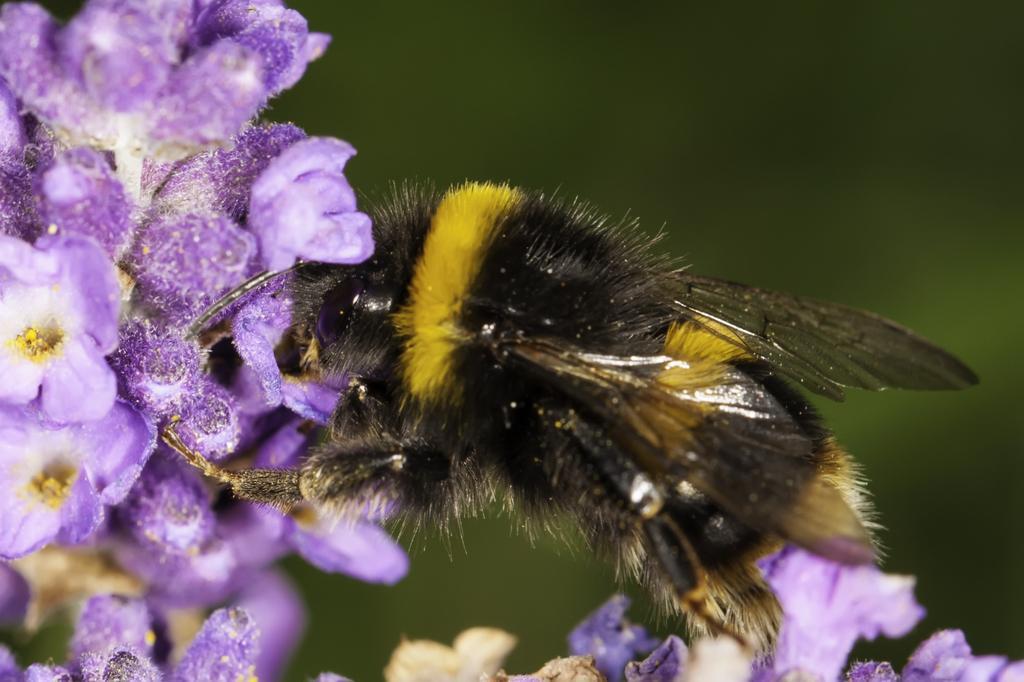In one or two sentences, can you explain what this image depicts? In this image there is a honey bee on the flowers which are in violet color. Background is in green color. Bottom of the image there are few flowers and buds. 